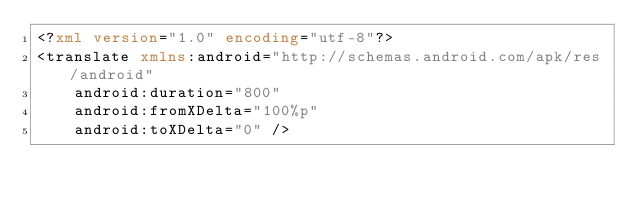Convert code to text. <code><loc_0><loc_0><loc_500><loc_500><_XML_><?xml version="1.0" encoding="utf-8"?>
<translate xmlns:android="http://schemas.android.com/apk/res/android"
    android:duration="800"
    android:fromXDelta="100%p"
    android:toXDelta="0" /></code> 